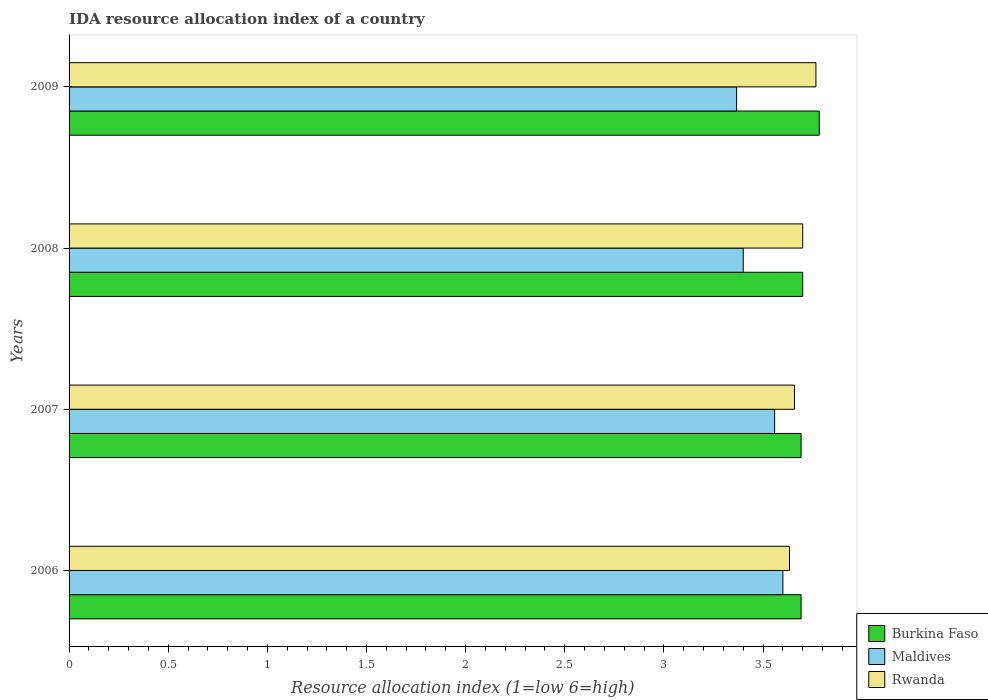How many different coloured bars are there?
Keep it short and to the point. 3. How many groups of bars are there?
Keep it short and to the point. 4. Are the number of bars per tick equal to the number of legend labels?
Offer a terse response. Yes. How many bars are there on the 1st tick from the top?
Your response must be concise. 3. What is the label of the 4th group of bars from the top?
Provide a short and direct response. 2006. In how many cases, is the number of bars for a given year not equal to the number of legend labels?
Your answer should be compact. 0. What is the IDA resource allocation index in Maldives in 2009?
Offer a very short reply. 3.37. Across all years, what is the maximum IDA resource allocation index in Burkina Faso?
Make the answer very short. 3.78. Across all years, what is the minimum IDA resource allocation index in Rwanda?
Your answer should be compact. 3.63. In which year was the IDA resource allocation index in Maldives maximum?
Provide a succinct answer. 2006. What is the total IDA resource allocation index in Rwanda in the graph?
Keep it short and to the point. 14.76. What is the difference between the IDA resource allocation index in Maldives in 2006 and that in 2009?
Provide a succinct answer. 0.23. What is the difference between the IDA resource allocation index in Burkina Faso in 2009 and the IDA resource allocation index in Rwanda in 2008?
Offer a very short reply. 0.08. What is the average IDA resource allocation index in Burkina Faso per year?
Your answer should be compact. 3.72. In the year 2006, what is the difference between the IDA resource allocation index in Burkina Faso and IDA resource allocation index in Rwanda?
Offer a very short reply. 0.06. In how many years, is the IDA resource allocation index in Burkina Faso greater than 3.4 ?
Provide a succinct answer. 4. What is the ratio of the IDA resource allocation index in Burkina Faso in 2006 to that in 2008?
Make the answer very short. 1. Is the difference between the IDA resource allocation index in Burkina Faso in 2008 and 2009 greater than the difference between the IDA resource allocation index in Rwanda in 2008 and 2009?
Your answer should be compact. No. What is the difference between the highest and the second highest IDA resource allocation index in Maldives?
Provide a succinct answer. 0.04. What is the difference between the highest and the lowest IDA resource allocation index in Rwanda?
Your answer should be compact. 0.13. Is the sum of the IDA resource allocation index in Burkina Faso in 2006 and 2007 greater than the maximum IDA resource allocation index in Rwanda across all years?
Offer a very short reply. Yes. What does the 3rd bar from the top in 2007 represents?
Make the answer very short. Burkina Faso. What does the 1st bar from the bottom in 2006 represents?
Offer a terse response. Burkina Faso. Is it the case that in every year, the sum of the IDA resource allocation index in Rwanda and IDA resource allocation index in Maldives is greater than the IDA resource allocation index in Burkina Faso?
Your answer should be compact. Yes. What is the difference between two consecutive major ticks on the X-axis?
Provide a short and direct response. 0.5. Does the graph contain any zero values?
Your answer should be very brief. No. Where does the legend appear in the graph?
Make the answer very short. Bottom right. How many legend labels are there?
Offer a terse response. 3. What is the title of the graph?
Your answer should be compact. IDA resource allocation index of a country. What is the label or title of the X-axis?
Your response must be concise. Resource allocation index (1=low 6=high). What is the Resource allocation index (1=low 6=high) of Burkina Faso in 2006?
Make the answer very short. 3.69. What is the Resource allocation index (1=low 6=high) in Rwanda in 2006?
Your response must be concise. 3.63. What is the Resource allocation index (1=low 6=high) in Burkina Faso in 2007?
Offer a very short reply. 3.69. What is the Resource allocation index (1=low 6=high) of Maldives in 2007?
Make the answer very short. 3.56. What is the Resource allocation index (1=low 6=high) in Rwanda in 2007?
Ensure brevity in your answer.  3.66. What is the Resource allocation index (1=low 6=high) of Rwanda in 2008?
Ensure brevity in your answer.  3.7. What is the Resource allocation index (1=low 6=high) of Burkina Faso in 2009?
Make the answer very short. 3.78. What is the Resource allocation index (1=low 6=high) of Maldives in 2009?
Ensure brevity in your answer.  3.37. What is the Resource allocation index (1=low 6=high) of Rwanda in 2009?
Provide a succinct answer. 3.77. Across all years, what is the maximum Resource allocation index (1=low 6=high) of Burkina Faso?
Give a very brief answer. 3.78. Across all years, what is the maximum Resource allocation index (1=low 6=high) of Rwanda?
Keep it short and to the point. 3.77. Across all years, what is the minimum Resource allocation index (1=low 6=high) of Burkina Faso?
Make the answer very short. 3.69. Across all years, what is the minimum Resource allocation index (1=low 6=high) in Maldives?
Make the answer very short. 3.37. Across all years, what is the minimum Resource allocation index (1=low 6=high) in Rwanda?
Keep it short and to the point. 3.63. What is the total Resource allocation index (1=low 6=high) in Burkina Faso in the graph?
Your answer should be compact. 14.87. What is the total Resource allocation index (1=low 6=high) of Maldives in the graph?
Give a very brief answer. 13.93. What is the total Resource allocation index (1=low 6=high) in Rwanda in the graph?
Make the answer very short. 14.76. What is the difference between the Resource allocation index (1=low 6=high) in Burkina Faso in 2006 and that in 2007?
Offer a very short reply. 0. What is the difference between the Resource allocation index (1=low 6=high) of Maldives in 2006 and that in 2007?
Provide a short and direct response. 0.04. What is the difference between the Resource allocation index (1=low 6=high) in Rwanda in 2006 and that in 2007?
Provide a short and direct response. -0.03. What is the difference between the Resource allocation index (1=low 6=high) of Burkina Faso in 2006 and that in 2008?
Provide a short and direct response. -0.01. What is the difference between the Resource allocation index (1=low 6=high) in Maldives in 2006 and that in 2008?
Make the answer very short. 0.2. What is the difference between the Resource allocation index (1=low 6=high) of Rwanda in 2006 and that in 2008?
Keep it short and to the point. -0.07. What is the difference between the Resource allocation index (1=low 6=high) of Burkina Faso in 2006 and that in 2009?
Keep it short and to the point. -0.09. What is the difference between the Resource allocation index (1=low 6=high) of Maldives in 2006 and that in 2009?
Provide a short and direct response. 0.23. What is the difference between the Resource allocation index (1=low 6=high) of Rwanda in 2006 and that in 2009?
Offer a terse response. -0.13. What is the difference between the Resource allocation index (1=low 6=high) of Burkina Faso in 2007 and that in 2008?
Your answer should be compact. -0.01. What is the difference between the Resource allocation index (1=low 6=high) in Maldives in 2007 and that in 2008?
Your response must be concise. 0.16. What is the difference between the Resource allocation index (1=low 6=high) in Rwanda in 2007 and that in 2008?
Offer a terse response. -0.04. What is the difference between the Resource allocation index (1=low 6=high) in Burkina Faso in 2007 and that in 2009?
Offer a very short reply. -0.09. What is the difference between the Resource allocation index (1=low 6=high) of Maldives in 2007 and that in 2009?
Keep it short and to the point. 0.19. What is the difference between the Resource allocation index (1=low 6=high) in Rwanda in 2007 and that in 2009?
Ensure brevity in your answer.  -0.11. What is the difference between the Resource allocation index (1=low 6=high) in Burkina Faso in 2008 and that in 2009?
Keep it short and to the point. -0.08. What is the difference between the Resource allocation index (1=low 6=high) of Rwanda in 2008 and that in 2009?
Make the answer very short. -0.07. What is the difference between the Resource allocation index (1=low 6=high) in Burkina Faso in 2006 and the Resource allocation index (1=low 6=high) in Maldives in 2007?
Your answer should be very brief. 0.13. What is the difference between the Resource allocation index (1=low 6=high) of Maldives in 2006 and the Resource allocation index (1=low 6=high) of Rwanda in 2007?
Your response must be concise. -0.06. What is the difference between the Resource allocation index (1=low 6=high) of Burkina Faso in 2006 and the Resource allocation index (1=low 6=high) of Maldives in 2008?
Ensure brevity in your answer.  0.29. What is the difference between the Resource allocation index (1=low 6=high) of Burkina Faso in 2006 and the Resource allocation index (1=low 6=high) of Rwanda in 2008?
Give a very brief answer. -0.01. What is the difference between the Resource allocation index (1=low 6=high) of Burkina Faso in 2006 and the Resource allocation index (1=low 6=high) of Maldives in 2009?
Provide a succinct answer. 0.33. What is the difference between the Resource allocation index (1=low 6=high) of Burkina Faso in 2006 and the Resource allocation index (1=low 6=high) of Rwanda in 2009?
Your answer should be very brief. -0.07. What is the difference between the Resource allocation index (1=low 6=high) in Maldives in 2006 and the Resource allocation index (1=low 6=high) in Rwanda in 2009?
Offer a terse response. -0.17. What is the difference between the Resource allocation index (1=low 6=high) of Burkina Faso in 2007 and the Resource allocation index (1=low 6=high) of Maldives in 2008?
Make the answer very short. 0.29. What is the difference between the Resource allocation index (1=low 6=high) of Burkina Faso in 2007 and the Resource allocation index (1=low 6=high) of Rwanda in 2008?
Keep it short and to the point. -0.01. What is the difference between the Resource allocation index (1=low 6=high) of Maldives in 2007 and the Resource allocation index (1=low 6=high) of Rwanda in 2008?
Provide a short and direct response. -0.14. What is the difference between the Resource allocation index (1=low 6=high) in Burkina Faso in 2007 and the Resource allocation index (1=low 6=high) in Maldives in 2009?
Keep it short and to the point. 0.33. What is the difference between the Resource allocation index (1=low 6=high) in Burkina Faso in 2007 and the Resource allocation index (1=low 6=high) in Rwanda in 2009?
Ensure brevity in your answer.  -0.07. What is the difference between the Resource allocation index (1=low 6=high) of Maldives in 2007 and the Resource allocation index (1=low 6=high) of Rwanda in 2009?
Your answer should be compact. -0.21. What is the difference between the Resource allocation index (1=low 6=high) in Burkina Faso in 2008 and the Resource allocation index (1=low 6=high) in Rwanda in 2009?
Ensure brevity in your answer.  -0.07. What is the difference between the Resource allocation index (1=low 6=high) in Maldives in 2008 and the Resource allocation index (1=low 6=high) in Rwanda in 2009?
Give a very brief answer. -0.37. What is the average Resource allocation index (1=low 6=high) of Burkina Faso per year?
Ensure brevity in your answer.  3.72. What is the average Resource allocation index (1=low 6=high) of Maldives per year?
Keep it short and to the point. 3.48. What is the average Resource allocation index (1=low 6=high) of Rwanda per year?
Give a very brief answer. 3.69. In the year 2006, what is the difference between the Resource allocation index (1=low 6=high) of Burkina Faso and Resource allocation index (1=low 6=high) of Maldives?
Make the answer very short. 0.09. In the year 2006, what is the difference between the Resource allocation index (1=low 6=high) of Burkina Faso and Resource allocation index (1=low 6=high) of Rwanda?
Make the answer very short. 0.06. In the year 2006, what is the difference between the Resource allocation index (1=low 6=high) of Maldives and Resource allocation index (1=low 6=high) of Rwanda?
Provide a succinct answer. -0.03. In the year 2007, what is the difference between the Resource allocation index (1=low 6=high) of Burkina Faso and Resource allocation index (1=low 6=high) of Maldives?
Make the answer very short. 0.13. In the year 2007, what is the difference between the Resource allocation index (1=low 6=high) in Maldives and Resource allocation index (1=low 6=high) in Rwanda?
Your response must be concise. -0.1. In the year 2008, what is the difference between the Resource allocation index (1=low 6=high) of Burkina Faso and Resource allocation index (1=low 6=high) of Maldives?
Offer a terse response. 0.3. In the year 2009, what is the difference between the Resource allocation index (1=low 6=high) in Burkina Faso and Resource allocation index (1=low 6=high) in Maldives?
Provide a succinct answer. 0.42. In the year 2009, what is the difference between the Resource allocation index (1=low 6=high) of Burkina Faso and Resource allocation index (1=low 6=high) of Rwanda?
Provide a short and direct response. 0.02. What is the ratio of the Resource allocation index (1=low 6=high) of Burkina Faso in 2006 to that in 2007?
Offer a very short reply. 1. What is the ratio of the Resource allocation index (1=low 6=high) of Maldives in 2006 to that in 2007?
Ensure brevity in your answer.  1.01. What is the ratio of the Resource allocation index (1=low 6=high) of Burkina Faso in 2006 to that in 2008?
Keep it short and to the point. 1. What is the ratio of the Resource allocation index (1=low 6=high) in Maldives in 2006 to that in 2008?
Keep it short and to the point. 1.06. What is the ratio of the Resource allocation index (1=low 6=high) of Burkina Faso in 2006 to that in 2009?
Ensure brevity in your answer.  0.98. What is the ratio of the Resource allocation index (1=low 6=high) of Maldives in 2006 to that in 2009?
Your answer should be compact. 1.07. What is the ratio of the Resource allocation index (1=low 6=high) in Rwanda in 2006 to that in 2009?
Provide a short and direct response. 0.96. What is the ratio of the Resource allocation index (1=low 6=high) of Burkina Faso in 2007 to that in 2008?
Your answer should be very brief. 1. What is the ratio of the Resource allocation index (1=low 6=high) of Maldives in 2007 to that in 2008?
Provide a succinct answer. 1.05. What is the ratio of the Resource allocation index (1=low 6=high) in Rwanda in 2007 to that in 2008?
Your response must be concise. 0.99. What is the ratio of the Resource allocation index (1=low 6=high) of Burkina Faso in 2007 to that in 2009?
Make the answer very short. 0.98. What is the ratio of the Resource allocation index (1=low 6=high) of Maldives in 2007 to that in 2009?
Keep it short and to the point. 1.06. What is the ratio of the Resource allocation index (1=low 6=high) of Rwanda in 2007 to that in 2009?
Make the answer very short. 0.97. What is the ratio of the Resource allocation index (1=low 6=high) in Burkina Faso in 2008 to that in 2009?
Offer a very short reply. 0.98. What is the ratio of the Resource allocation index (1=low 6=high) in Maldives in 2008 to that in 2009?
Keep it short and to the point. 1.01. What is the ratio of the Resource allocation index (1=low 6=high) of Rwanda in 2008 to that in 2009?
Provide a short and direct response. 0.98. What is the difference between the highest and the second highest Resource allocation index (1=low 6=high) in Burkina Faso?
Your answer should be very brief. 0.08. What is the difference between the highest and the second highest Resource allocation index (1=low 6=high) in Maldives?
Make the answer very short. 0.04. What is the difference between the highest and the second highest Resource allocation index (1=low 6=high) in Rwanda?
Make the answer very short. 0.07. What is the difference between the highest and the lowest Resource allocation index (1=low 6=high) in Burkina Faso?
Your answer should be compact. 0.09. What is the difference between the highest and the lowest Resource allocation index (1=low 6=high) in Maldives?
Your answer should be compact. 0.23. What is the difference between the highest and the lowest Resource allocation index (1=low 6=high) of Rwanda?
Your answer should be compact. 0.13. 